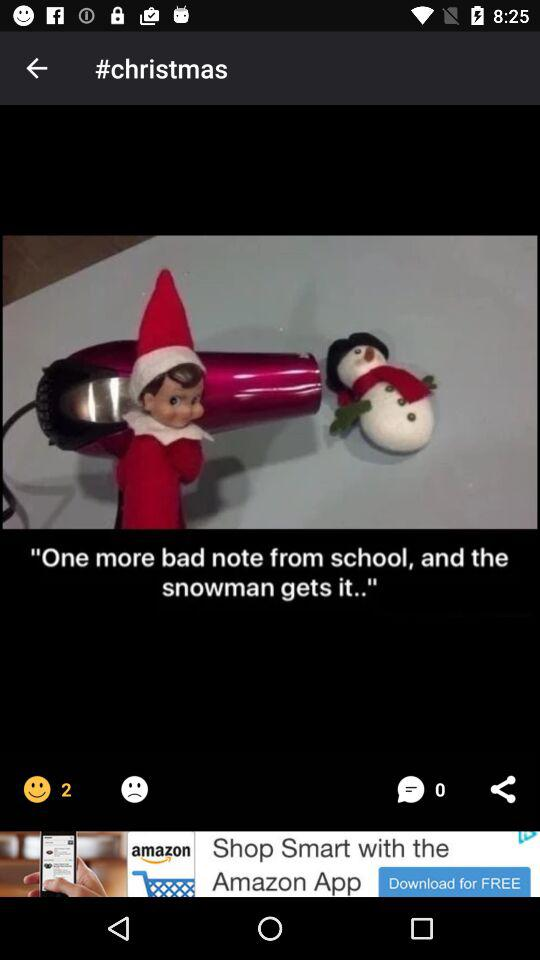What is the count of the happy emojis? The count is 2. 